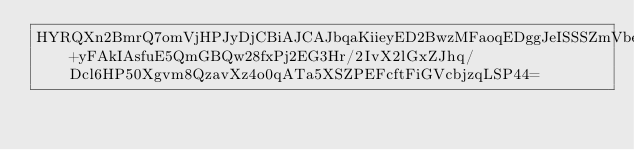<code> <loc_0><loc_0><loc_500><loc_500><_SML_>HYRQXn2BmrQ7omVjHPJyDjCBiAJCAJbqaKiieyED2BwzMFaoqEDggJeISSSZmVbeTCxIio2x64pM6ygO3fE02qWrS265b3CYz0HNiYx30oqUpYZ9O+yFAkIAsfuE5QmGBQw28fxPj2EG3Hr/2IvX2lGxZJhq/Dcl6HP50Xgvm8QzavXz4o0qATa5XSZPEFcftFiGVcbjzqLSP44=</code> 